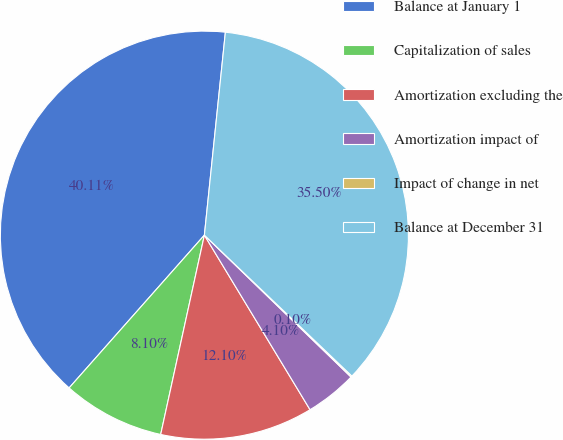Convert chart. <chart><loc_0><loc_0><loc_500><loc_500><pie_chart><fcel>Balance at January 1<fcel>Capitalization of sales<fcel>Amortization excluding the<fcel>Amortization impact of<fcel>Impact of change in net<fcel>Balance at December 31<nl><fcel>40.11%<fcel>8.1%<fcel>12.1%<fcel>4.1%<fcel>0.1%<fcel>35.5%<nl></chart> 